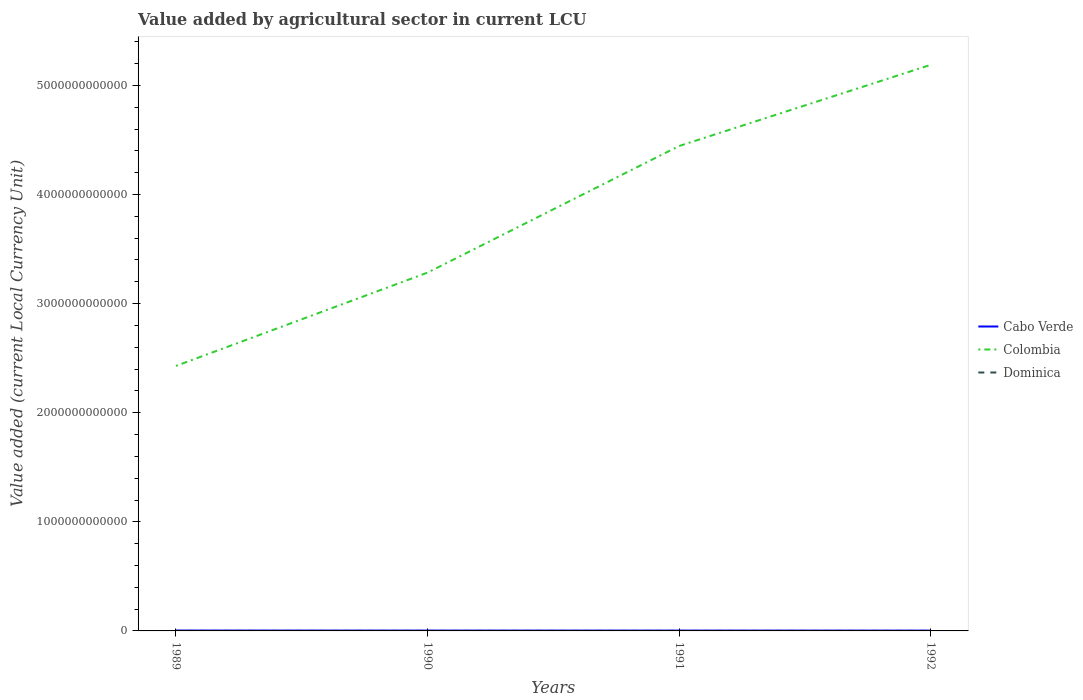How many different coloured lines are there?
Offer a terse response. 3. Across all years, what is the maximum value added by agricultural sector in Cabo Verde?
Ensure brevity in your answer.  2.87e+09. In which year was the value added by agricultural sector in Cabo Verde maximum?
Give a very brief answer. 1992. What is the total value added by agricultural sector in Dominica in the graph?
Provide a short and direct response. -4.42e+06. What is the difference between the highest and the second highest value added by agricultural sector in Cabo Verde?
Give a very brief answer. 5.16e+08. What is the difference between the highest and the lowest value added by agricultural sector in Colombia?
Give a very brief answer. 2. How many lines are there?
Your answer should be very brief. 3. What is the difference between two consecutive major ticks on the Y-axis?
Offer a terse response. 1.00e+12. How many legend labels are there?
Your response must be concise. 3. How are the legend labels stacked?
Offer a very short reply. Vertical. What is the title of the graph?
Your response must be concise. Value added by agricultural sector in current LCU. What is the label or title of the Y-axis?
Give a very brief answer. Value added (current Local Currency Unit). What is the Value added (current Local Currency Unit) in Cabo Verde in 1989?
Offer a very short reply. 3.38e+09. What is the Value added (current Local Currency Unit) of Colombia in 1989?
Give a very brief answer. 2.43e+12. What is the Value added (current Local Currency Unit) of Dominica in 1989?
Make the answer very short. 8.09e+07. What is the Value added (current Local Currency Unit) in Cabo Verde in 1990?
Keep it short and to the point. 3.09e+09. What is the Value added (current Local Currency Unit) in Colombia in 1990?
Keep it short and to the point. 3.28e+12. What is the Value added (current Local Currency Unit) in Dominica in 1990?
Offer a terse response. 9.25e+07. What is the Value added (current Local Currency Unit) of Cabo Verde in 1991?
Offer a terse response. 3.06e+09. What is the Value added (current Local Currency Unit) in Colombia in 1991?
Offer a very short reply. 4.44e+12. What is the Value added (current Local Currency Unit) in Dominica in 1991?
Ensure brevity in your answer.  9.69e+07. What is the Value added (current Local Currency Unit) of Cabo Verde in 1992?
Give a very brief answer. 2.87e+09. What is the Value added (current Local Currency Unit) in Colombia in 1992?
Provide a short and direct response. 5.19e+12. What is the Value added (current Local Currency Unit) of Dominica in 1992?
Offer a very short reply. 9.76e+07. Across all years, what is the maximum Value added (current Local Currency Unit) in Cabo Verde?
Ensure brevity in your answer.  3.38e+09. Across all years, what is the maximum Value added (current Local Currency Unit) of Colombia?
Your answer should be compact. 5.19e+12. Across all years, what is the maximum Value added (current Local Currency Unit) in Dominica?
Provide a succinct answer. 9.76e+07. Across all years, what is the minimum Value added (current Local Currency Unit) in Cabo Verde?
Ensure brevity in your answer.  2.87e+09. Across all years, what is the minimum Value added (current Local Currency Unit) of Colombia?
Give a very brief answer. 2.43e+12. Across all years, what is the minimum Value added (current Local Currency Unit) of Dominica?
Keep it short and to the point. 8.09e+07. What is the total Value added (current Local Currency Unit) in Cabo Verde in the graph?
Provide a short and direct response. 1.24e+1. What is the total Value added (current Local Currency Unit) in Colombia in the graph?
Offer a very short reply. 1.53e+13. What is the total Value added (current Local Currency Unit) in Dominica in the graph?
Keep it short and to the point. 3.68e+08. What is the difference between the Value added (current Local Currency Unit) in Cabo Verde in 1989 and that in 1990?
Provide a short and direct response. 2.88e+08. What is the difference between the Value added (current Local Currency Unit) of Colombia in 1989 and that in 1990?
Provide a succinct answer. -8.55e+11. What is the difference between the Value added (current Local Currency Unit) of Dominica in 1989 and that in 1990?
Your answer should be compact. -1.16e+07. What is the difference between the Value added (current Local Currency Unit) in Cabo Verde in 1989 and that in 1991?
Make the answer very short. 3.22e+08. What is the difference between the Value added (current Local Currency Unit) of Colombia in 1989 and that in 1991?
Keep it short and to the point. -2.02e+12. What is the difference between the Value added (current Local Currency Unit) of Dominica in 1989 and that in 1991?
Offer a terse response. -1.60e+07. What is the difference between the Value added (current Local Currency Unit) of Cabo Verde in 1989 and that in 1992?
Your answer should be compact. 5.16e+08. What is the difference between the Value added (current Local Currency Unit) of Colombia in 1989 and that in 1992?
Your response must be concise. -2.76e+12. What is the difference between the Value added (current Local Currency Unit) of Dominica in 1989 and that in 1992?
Give a very brief answer. -1.67e+07. What is the difference between the Value added (current Local Currency Unit) in Cabo Verde in 1990 and that in 1991?
Offer a very short reply. 3.41e+07. What is the difference between the Value added (current Local Currency Unit) of Colombia in 1990 and that in 1991?
Keep it short and to the point. -1.16e+12. What is the difference between the Value added (current Local Currency Unit) of Dominica in 1990 and that in 1991?
Provide a short and direct response. -4.42e+06. What is the difference between the Value added (current Local Currency Unit) in Cabo Verde in 1990 and that in 1992?
Your answer should be compact. 2.28e+08. What is the difference between the Value added (current Local Currency Unit) of Colombia in 1990 and that in 1992?
Provide a short and direct response. -1.90e+12. What is the difference between the Value added (current Local Currency Unit) in Dominica in 1990 and that in 1992?
Make the answer very short. -5.13e+06. What is the difference between the Value added (current Local Currency Unit) in Cabo Verde in 1991 and that in 1992?
Make the answer very short. 1.94e+08. What is the difference between the Value added (current Local Currency Unit) of Colombia in 1991 and that in 1992?
Ensure brevity in your answer.  -7.44e+11. What is the difference between the Value added (current Local Currency Unit) of Dominica in 1991 and that in 1992?
Provide a short and direct response. -7.10e+05. What is the difference between the Value added (current Local Currency Unit) in Cabo Verde in 1989 and the Value added (current Local Currency Unit) in Colombia in 1990?
Make the answer very short. -3.28e+12. What is the difference between the Value added (current Local Currency Unit) in Cabo Verde in 1989 and the Value added (current Local Currency Unit) in Dominica in 1990?
Provide a short and direct response. 3.29e+09. What is the difference between the Value added (current Local Currency Unit) in Colombia in 1989 and the Value added (current Local Currency Unit) in Dominica in 1990?
Keep it short and to the point. 2.43e+12. What is the difference between the Value added (current Local Currency Unit) of Cabo Verde in 1989 and the Value added (current Local Currency Unit) of Colombia in 1991?
Keep it short and to the point. -4.44e+12. What is the difference between the Value added (current Local Currency Unit) of Cabo Verde in 1989 and the Value added (current Local Currency Unit) of Dominica in 1991?
Offer a terse response. 3.28e+09. What is the difference between the Value added (current Local Currency Unit) of Colombia in 1989 and the Value added (current Local Currency Unit) of Dominica in 1991?
Your answer should be compact. 2.43e+12. What is the difference between the Value added (current Local Currency Unit) in Cabo Verde in 1989 and the Value added (current Local Currency Unit) in Colombia in 1992?
Give a very brief answer. -5.19e+12. What is the difference between the Value added (current Local Currency Unit) in Cabo Verde in 1989 and the Value added (current Local Currency Unit) in Dominica in 1992?
Provide a succinct answer. 3.28e+09. What is the difference between the Value added (current Local Currency Unit) in Colombia in 1989 and the Value added (current Local Currency Unit) in Dominica in 1992?
Provide a short and direct response. 2.43e+12. What is the difference between the Value added (current Local Currency Unit) in Cabo Verde in 1990 and the Value added (current Local Currency Unit) in Colombia in 1991?
Your response must be concise. -4.44e+12. What is the difference between the Value added (current Local Currency Unit) in Cabo Verde in 1990 and the Value added (current Local Currency Unit) in Dominica in 1991?
Keep it short and to the point. 3.00e+09. What is the difference between the Value added (current Local Currency Unit) of Colombia in 1990 and the Value added (current Local Currency Unit) of Dominica in 1991?
Keep it short and to the point. 3.28e+12. What is the difference between the Value added (current Local Currency Unit) of Cabo Verde in 1990 and the Value added (current Local Currency Unit) of Colombia in 1992?
Ensure brevity in your answer.  -5.19e+12. What is the difference between the Value added (current Local Currency Unit) in Cabo Verde in 1990 and the Value added (current Local Currency Unit) in Dominica in 1992?
Make the answer very short. 3.00e+09. What is the difference between the Value added (current Local Currency Unit) of Colombia in 1990 and the Value added (current Local Currency Unit) of Dominica in 1992?
Provide a succinct answer. 3.28e+12. What is the difference between the Value added (current Local Currency Unit) in Cabo Verde in 1991 and the Value added (current Local Currency Unit) in Colombia in 1992?
Your answer should be very brief. -5.19e+12. What is the difference between the Value added (current Local Currency Unit) of Cabo Verde in 1991 and the Value added (current Local Currency Unit) of Dominica in 1992?
Your answer should be very brief. 2.96e+09. What is the difference between the Value added (current Local Currency Unit) of Colombia in 1991 and the Value added (current Local Currency Unit) of Dominica in 1992?
Your answer should be very brief. 4.44e+12. What is the average Value added (current Local Currency Unit) in Cabo Verde per year?
Ensure brevity in your answer.  3.10e+09. What is the average Value added (current Local Currency Unit) of Colombia per year?
Give a very brief answer. 3.84e+12. What is the average Value added (current Local Currency Unit) in Dominica per year?
Offer a very short reply. 9.20e+07. In the year 1989, what is the difference between the Value added (current Local Currency Unit) in Cabo Verde and Value added (current Local Currency Unit) in Colombia?
Your answer should be very brief. -2.43e+12. In the year 1989, what is the difference between the Value added (current Local Currency Unit) in Cabo Verde and Value added (current Local Currency Unit) in Dominica?
Your answer should be compact. 3.30e+09. In the year 1989, what is the difference between the Value added (current Local Currency Unit) of Colombia and Value added (current Local Currency Unit) of Dominica?
Ensure brevity in your answer.  2.43e+12. In the year 1990, what is the difference between the Value added (current Local Currency Unit) of Cabo Verde and Value added (current Local Currency Unit) of Colombia?
Your response must be concise. -3.28e+12. In the year 1990, what is the difference between the Value added (current Local Currency Unit) of Cabo Verde and Value added (current Local Currency Unit) of Dominica?
Your answer should be compact. 3.00e+09. In the year 1990, what is the difference between the Value added (current Local Currency Unit) in Colombia and Value added (current Local Currency Unit) in Dominica?
Your answer should be compact. 3.28e+12. In the year 1991, what is the difference between the Value added (current Local Currency Unit) in Cabo Verde and Value added (current Local Currency Unit) in Colombia?
Offer a very short reply. -4.44e+12. In the year 1991, what is the difference between the Value added (current Local Currency Unit) in Cabo Verde and Value added (current Local Currency Unit) in Dominica?
Offer a very short reply. 2.96e+09. In the year 1991, what is the difference between the Value added (current Local Currency Unit) of Colombia and Value added (current Local Currency Unit) of Dominica?
Give a very brief answer. 4.44e+12. In the year 1992, what is the difference between the Value added (current Local Currency Unit) of Cabo Verde and Value added (current Local Currency Unit) of Colombia?
Provide a succinct answer. -5.19e+12. In the year 1992, what is the difference between the Value added (current Local Currency Unit) of Cabo Verde and Value added (current Local Currency Unit) of Dominica?
Keep it short and to the point. 2.77e+09. In the year 1992, what is the difference between the Value added (current Local Currency Unit) of Colombia and Value added (current Local Currency Unit) of Dominica?
Offer a terse response. 5.19e+12. What is the ratio of the Value added (current Local Currency Unit) in Cabo Verde in 1989 to that in 1990?
Your answer should be compact. 1.09. What is the ratio of the Value added (current Local Currency Unit) of Colombia in 1989 to that in 1990?
Ensure brevity in your answer.  0.74. What is the ratio of the Value added (current Local Currency Unit) in Dominica in 1989 to that in 1990?
Give a very brief answer. 0.88. What is the ratio of the Value added (current Local Currency Unit) in Cabo Verde in 1989 to that in 1991?
Offer a terse response. 1.11. What is the ratio of the Value added (current Local Currency Unit) of Colombia in 1989 to that in 1991?
Offer a terse response. 0.55. What is the ratio of the Value added (current Local Currency Unit) in Dominica in 1989 to that in 1991?
Provide a short and direct response. 0.84. What is the ratio of the Value added (current Local Currency Unit) of Cabo Verde in 1989 to that in 1992?
Keep it short and to the point. 1.18. What is the ratio of the Value added (current Local Currency Unit) of Colombia in 1989 to that in 1992?
Your answer should be very brief. 0.47. What is the ratio of the Value added (current Local Currency Unit) in Dominica in 1989 to that in 1992?
Your answer should be very brief. 0.83. What is the ratio of the Value added (current Local Currency Unit) in Cabo Verde in 1990 to that in 1991?
Your answer should be very brief. 1.01. What is the ratio of the Value added (current Local Currency Unit) of Colombia in 1990 to that in 1991?
Make the answer very short. 0.74. What is the ratio of the Value added (current Local Currency Unit) of Dominica in 1990 to that in 1991?
Your answer should be very brief. 0.95. What is the ratio of the Value added (current Local Currency Unit) of Cabo Verde in 1990 to that in 1992?
Your answer should be compact. 1.08. What is the ratio of the Value added (current Local Currency Unit) of Colombia in 1990 to that in 1992?
Keep it short and to the point. 0.63. What is the ratio of the Value added (current Local Currency Unit) of Cabo Verde in 1991 to that in 1992?
Ensure brevity in your answer.  1.07. What is the ratio of the Value added (current Local Currency Unit) in Colombia in 1991 to that in 1992?
Keep it short and to the point. 0.86. What is the difference between the highest and the second highest Value added (current Local Currency Unit) in Cabo Verde?
Keep it short and to the point. 2.88e+08. What is the difference between the highest and the second highest Value added (current Local Currency Unit) in Colombia?
Your response must be concise. 7.44e+11. What is the difference between the highest and the second highest Value added (current Local Currency Unit) of Dominica?
Your answer should be very brief. 7.10e+05. What is the difference between the highest and the lowest Value added (current Local Currency Unit) of Cabo Verde?
Offer a terse response. 5.16e+08. What is the difference between the highest and the lowest Value added (current Local Currency Unit) in Colombia?
Provide a short and direct response. 2.76e+12. What is the difference between the highest and the lowest Value added (current Local Currency Unit) in Dominica?
Make the answer very short. 1.67e+07. 